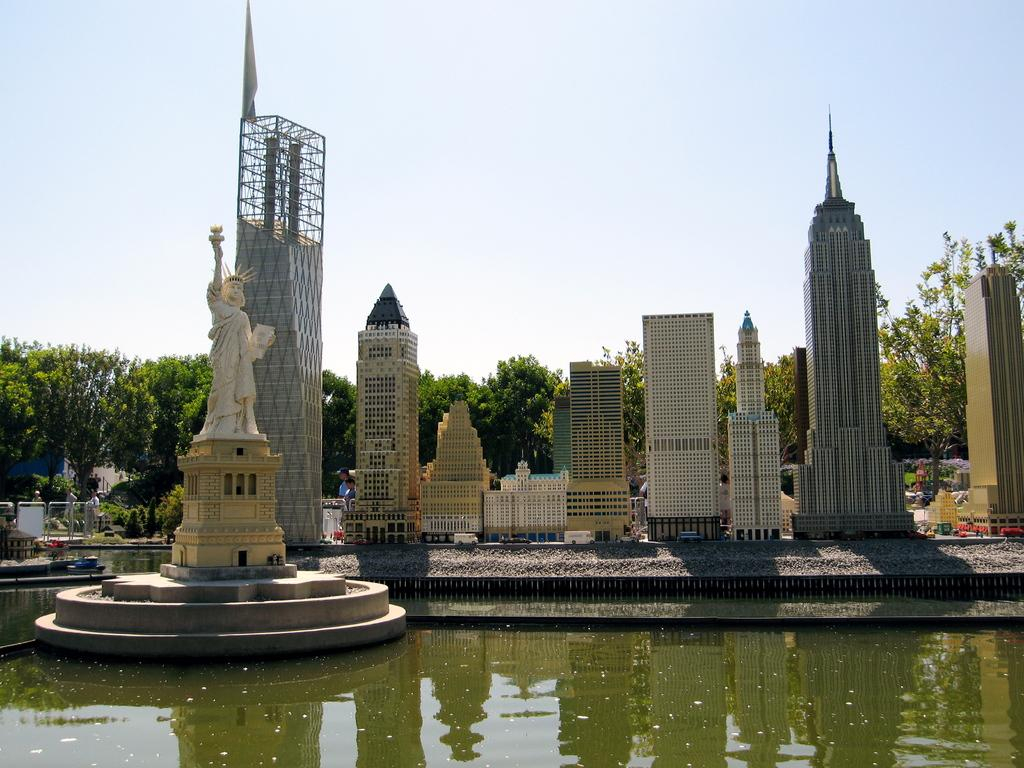What is located on the left side of the image? There is a statue on the left side of the image. What can be seen at the bottom of the image? There is water at the bottom of the image. What is in the center of the image? There are trees and buildings in the center of the image. What type of whip can be seen in the hands of the statue in the image? There is no whip present in the image; the statue does not have any objects in its hands. Is the story depicted in the image based on fiction or non-fiction? The image is a still representation and does not depict a story, so it cannot be classified as fiction or non-fiction. 